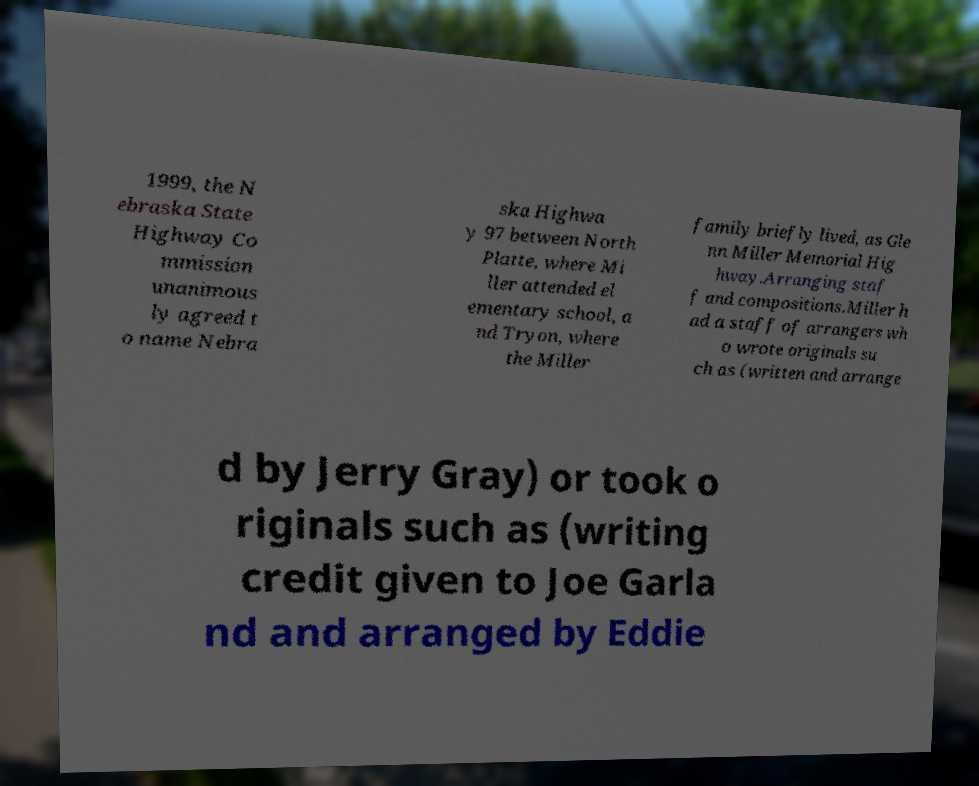There's text embedded in this image that I need extracted. Can you transcribe it verbatim? 1999, the N ebraska State Highway Co mmission unanimous ly agreed t o name Nebra ska Highwa y 97 between North Platte, where Mi ller attended el ementary school, a nd Tryon, where the Miller family briefly lived, as Gle nn Miller Memorial Hig hway.Arranging staf f and compositions.Miller h ad a staff of arrangers wh o wrote originals su ch as (written and arrange d by Jerry Gray) or took o riginals such as (writing credit given to Joe Garla nd and arranged by Eddie 